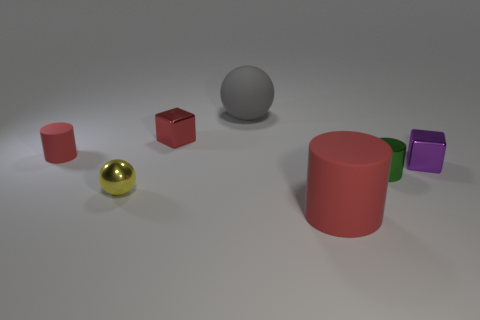There is a cube that is the same color as the small matte object; what material is it?
Provide a short and direct response. Metal. Is there a gray object of the same shape as the yellow metallic thing?
Your response must be concise. Yes. There is a small rubber cylinder; what number of small red objects are to the right of it?
Your response must be concise. 1. What is the material of the red cylinder on the left side of the large rubber thing that is behind the tiny matte cylinder?
Give a very brief answer. Rubber. There is a sphere that is the same size as the green metallic cylinder; what is its material?
Your response must be concise. Metal. Are there any red cylinders that have the same size as the yellow metal ball?
Offer a very short reply. Yes. What color is the rubber cylinder that is right of the big gray matte thing?
Provide a short and direct response. Red. There is a cylinder to the left of the gray rubber sphere; is there a purple block on the left side of it?
Offer a very short reply. No. How many other objects are there of the same color as the small metallic ball?
Keep it short and to the point. 0. Does the cube behind the purple metal cube have the same size as the red rubber cylinder in front of the small green cylinder?
Keep it short and to the point. No. 